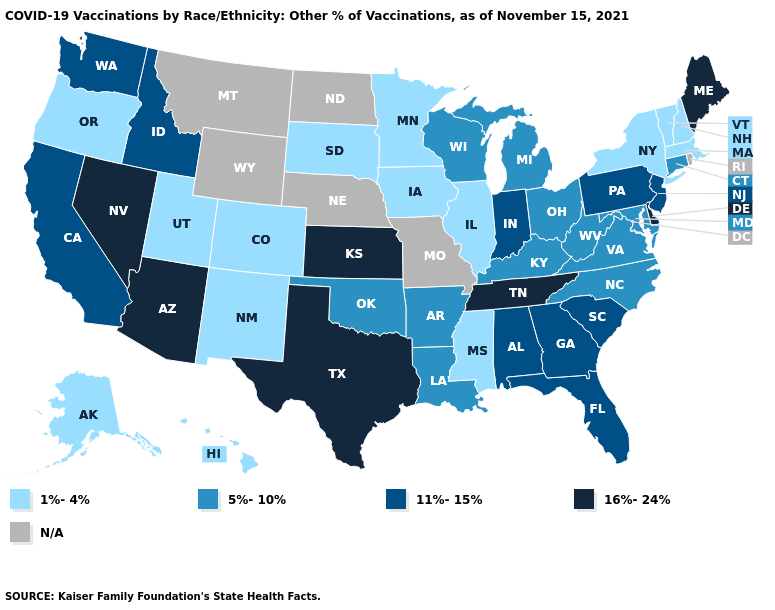Among the states that border Oregon , does Nevada have the highest value?
Keep it brief. Yes. Name the states that have a value in the range 16%-24%?
Write a very short answer. Arizona, Delaware, Kansas, Maine, Nevada, Tennessee, Texas. What is the value of South Carolina?
Concise answer only. 11%-15%. Among the states that border Massachusetts , which have the highest value?
Answer briefly. Connecticut. Among the states that border Arkansas , which have the highest value?
Keep it brief. Tennessee, Texas. What is the highest value in the USA?
Give a very brief answer. 16%-24%. Name the states that have a value in the range 1%-4%?
Quick response, please. Alaska, Colorado, Hawaii, Illinois, Iowa, Massachusetts, Minnesota, Mississippi, New Hampshire, New Mexico, New York, Oregon, South Dakota, Utah, Vermont. Does Mississippi have the lowest value in the South?
Keep it brief. Yes. Name the states that have a value in the range 1%-4%?
Write a very short answer. Alaska, Colorado, Hawaii, Illinois, Iowa, Massachusetts, Minnesota, Mississippi, New Hampshire, New Mexico, New York, Oregon, South Dakota, Utah, Vermont. Which states have the highest value in the USA?
Be succinct. Arizona, Delaware, Kansas, Maine, Nevada, Tennessee, Texas. Does Alabama have the lowest value in the South?
Short answer required. No. Does Massachusetts have the lowest value in the USA?
Keep it brief. Yes. What is the lowest value in states that border Connecticut?
Keep it brief. 1%-4%. Which states have the lowest value in the MidWest?
Answer briefly. Illinois, Iowa, Minnesota, South Dakota. Name the states that have a value in the range N/A?
Write a very short answer. Missouri, Montana, Nebraska, North Dakota, Rhode Island, Wyoming. 